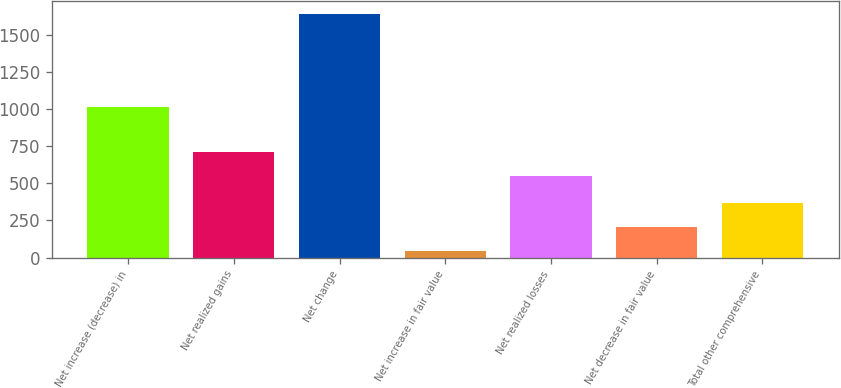<chart> <loc_0><loc_0><loc_500><loc_500><bar_chart><fcel>Net increase (decrease) in<fcel>Net realized gains<fcel>Net change<fcel>Net increase in fair value<fcel>Net realized losses<fcel>Net decrease in fair value<fcel>Total other comprehensive<nl><fcel>1017<fcel>710.8<fcel>1643<fcel>45<fcel>551<fcel>204.8<fcel>364.6<nl></chart> 